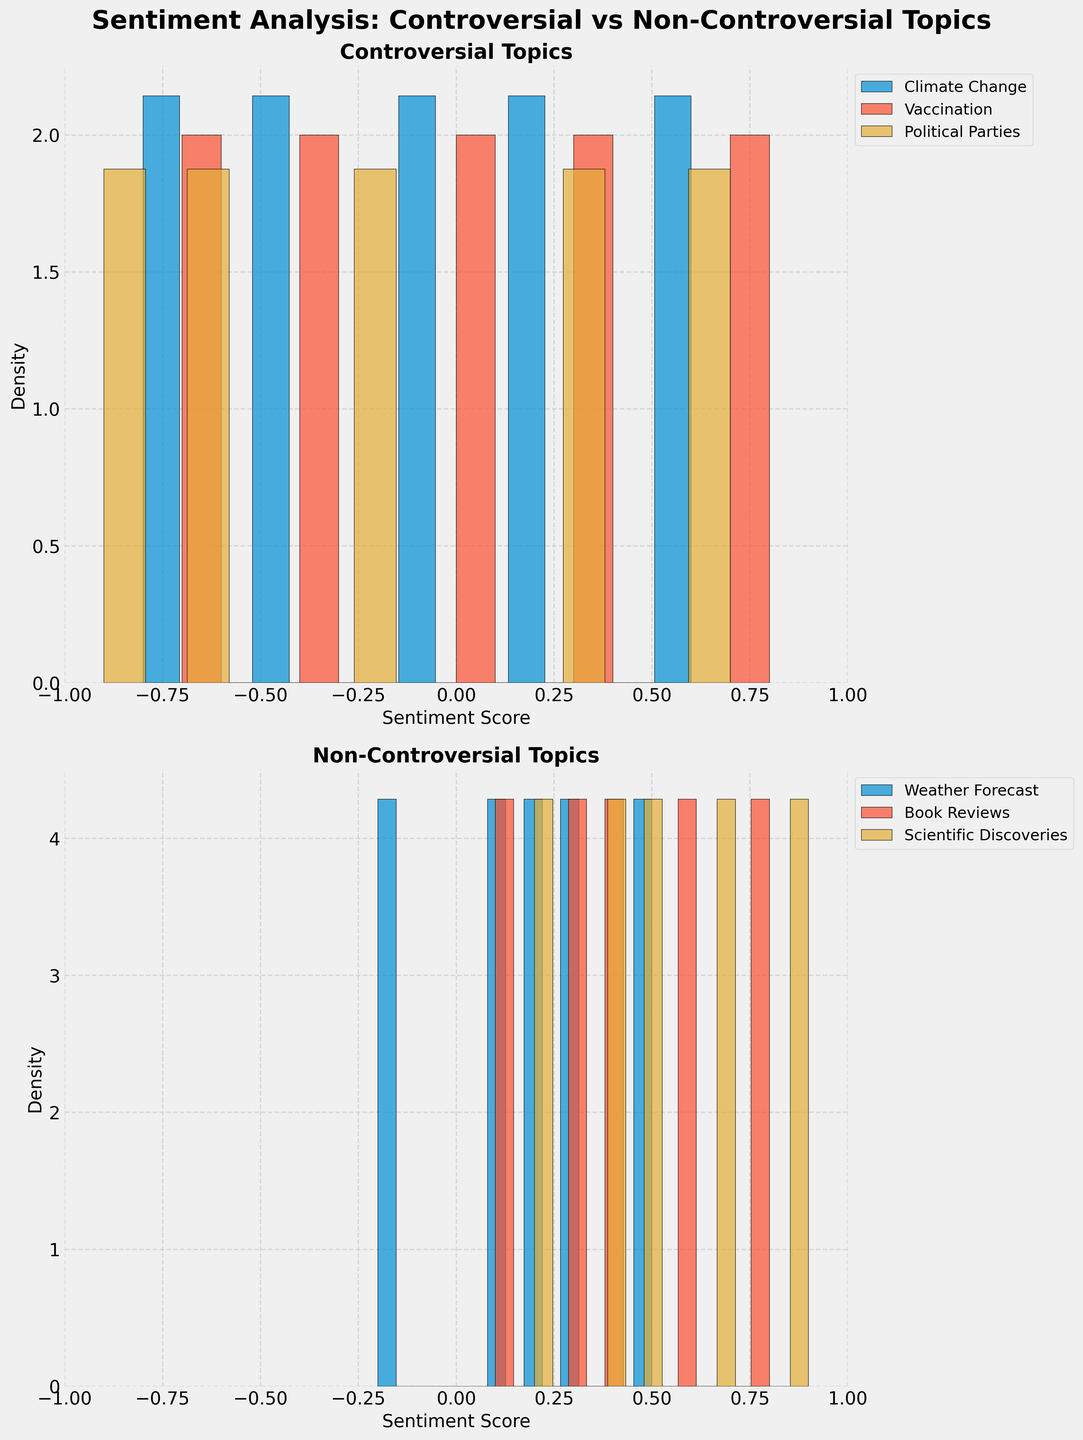What are the titles of the two subplots? The titles of the subplots are directly written above each subplot. In the figure, the title above the first subplot is "Controversial Topics," and the title above the second subplot is "Non-Controversial Topics."
Answer: Controversial Topics, Non-Controversial Topics What is the range of the x-axis in both subplots? The x-axis range can be observed by looking at the first and last tick marks on the x-axis of the subplots. In both the "Controversial Topics" and "Non-Controversial Topics" subplots, the x-axis ranges from -1 to 1.
Answer: -1 to 1 How many topics are represented in the controversial subplot compared to the non-controversial subplot? Count the number of different color segments (representing different topics) within the histograms of the two subplots. There are 3 topics in the controversial subplot ("Climate Change," "Vaccination," "Political Parties") and 3 topics in the non-controversial subplot ("Weather Forecast," "Book Reviews," "Scientific Discoveries").
Answer: Each subplot has 3 topics Which topic in the controversial subplot has the highest density around a positive sentiment score of 0.6 to 0.7? Check which histogram segment (color) has the highest bar height or density within the range of 0.6 to 0.7 in the "Controversial Topics" subplot. The topic "Political Parties" shows the highest density in this range.
Answer: Political Parties In the non-controversial subplot, which topic has the highest density peak, and what is its corresponding sentiment score? Find which colored segment in the non-controversial subplot has the highest peak, and note the x-value corresponding to its highest point. The topic "Scientific Discoveries" has the highest density peak around a sentiment score of 0.7.
Answer: Scientific Discoveries at 0.7 Are there any topics in the controversial subplot with greater density at negative sentiment scores than positive? Observe the histogram bars in the controversial subplot. The topics "Climate Change" and "Political Parties" show greater density peaks around negative sentiment scores compared to their positive sentiment scores.
Answer: Climate Change, Political Parties How does the range of sentiment scores in "Vaccination" (controversial) compare to "Book Reviews" (non-controversial)? Compare the span of the histogram bars along the x-axis for both topics. "Vaccination" has sentiment scores ranging from approximately -0.7 to 0.8, while "Book Reviews" range from approximately 0.1 to 0.8. "Vaccination" has a wider range of sentiment scores.
Answer: Vaccination has a wider range Which subplot displays more symmetrical density distributions around a sentiment score of 0? By observing the shape of the histograms around the sentiment score of 0, the non-controversial subplot shows more symmetrical distributions around 0, indicating a balance between positive and negative sentiments.
Answer: Non-controversial subplot Which controversial topic has the narrowest distribution of sentiment scores? Identify which histogram has a narrow spread by looking at the x-axis width of the colored segments. "Vaccination" exhibits the narrowest distribution of sentiment scores among the controversial topics.
Answer: Vaccination What can be inferred about the general sentiment scores of non-controversial topics from the figure? The peaks and the density of histogram bars indicate that most of the sentiment scores for non-controversial topics are positive and concentrated around the middle range (0 to 1).
Answer: Generally positive 